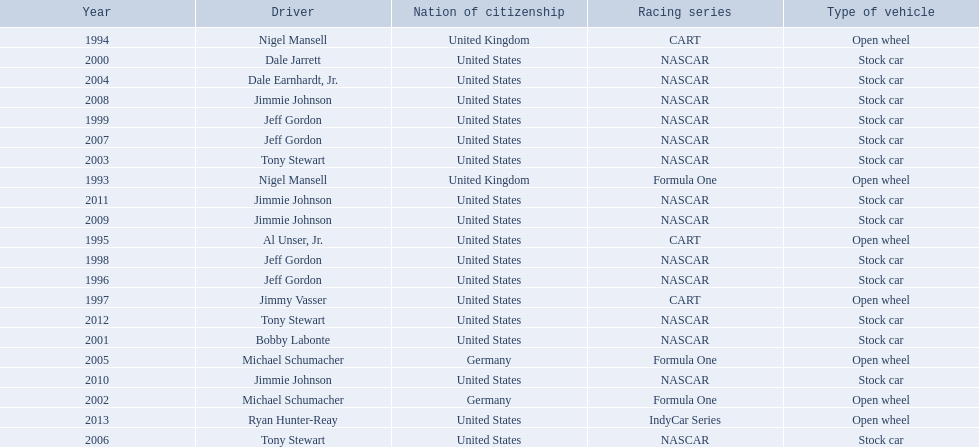Who won an espy in the year 2004, bobby labonte, tony stewart, dale earnhardt jr., or jeff gordon? Dale Earnhardt, Jr. Who won the espy in the year 1997; nigel mansell, al unser, jr., jeff gordon, or jimmy vasser? Jimmy Vasser. Which one only has one espy; nigel mansell, al unser jr., michael schumacher, or jeff gordon? Al Unser, Jr. 